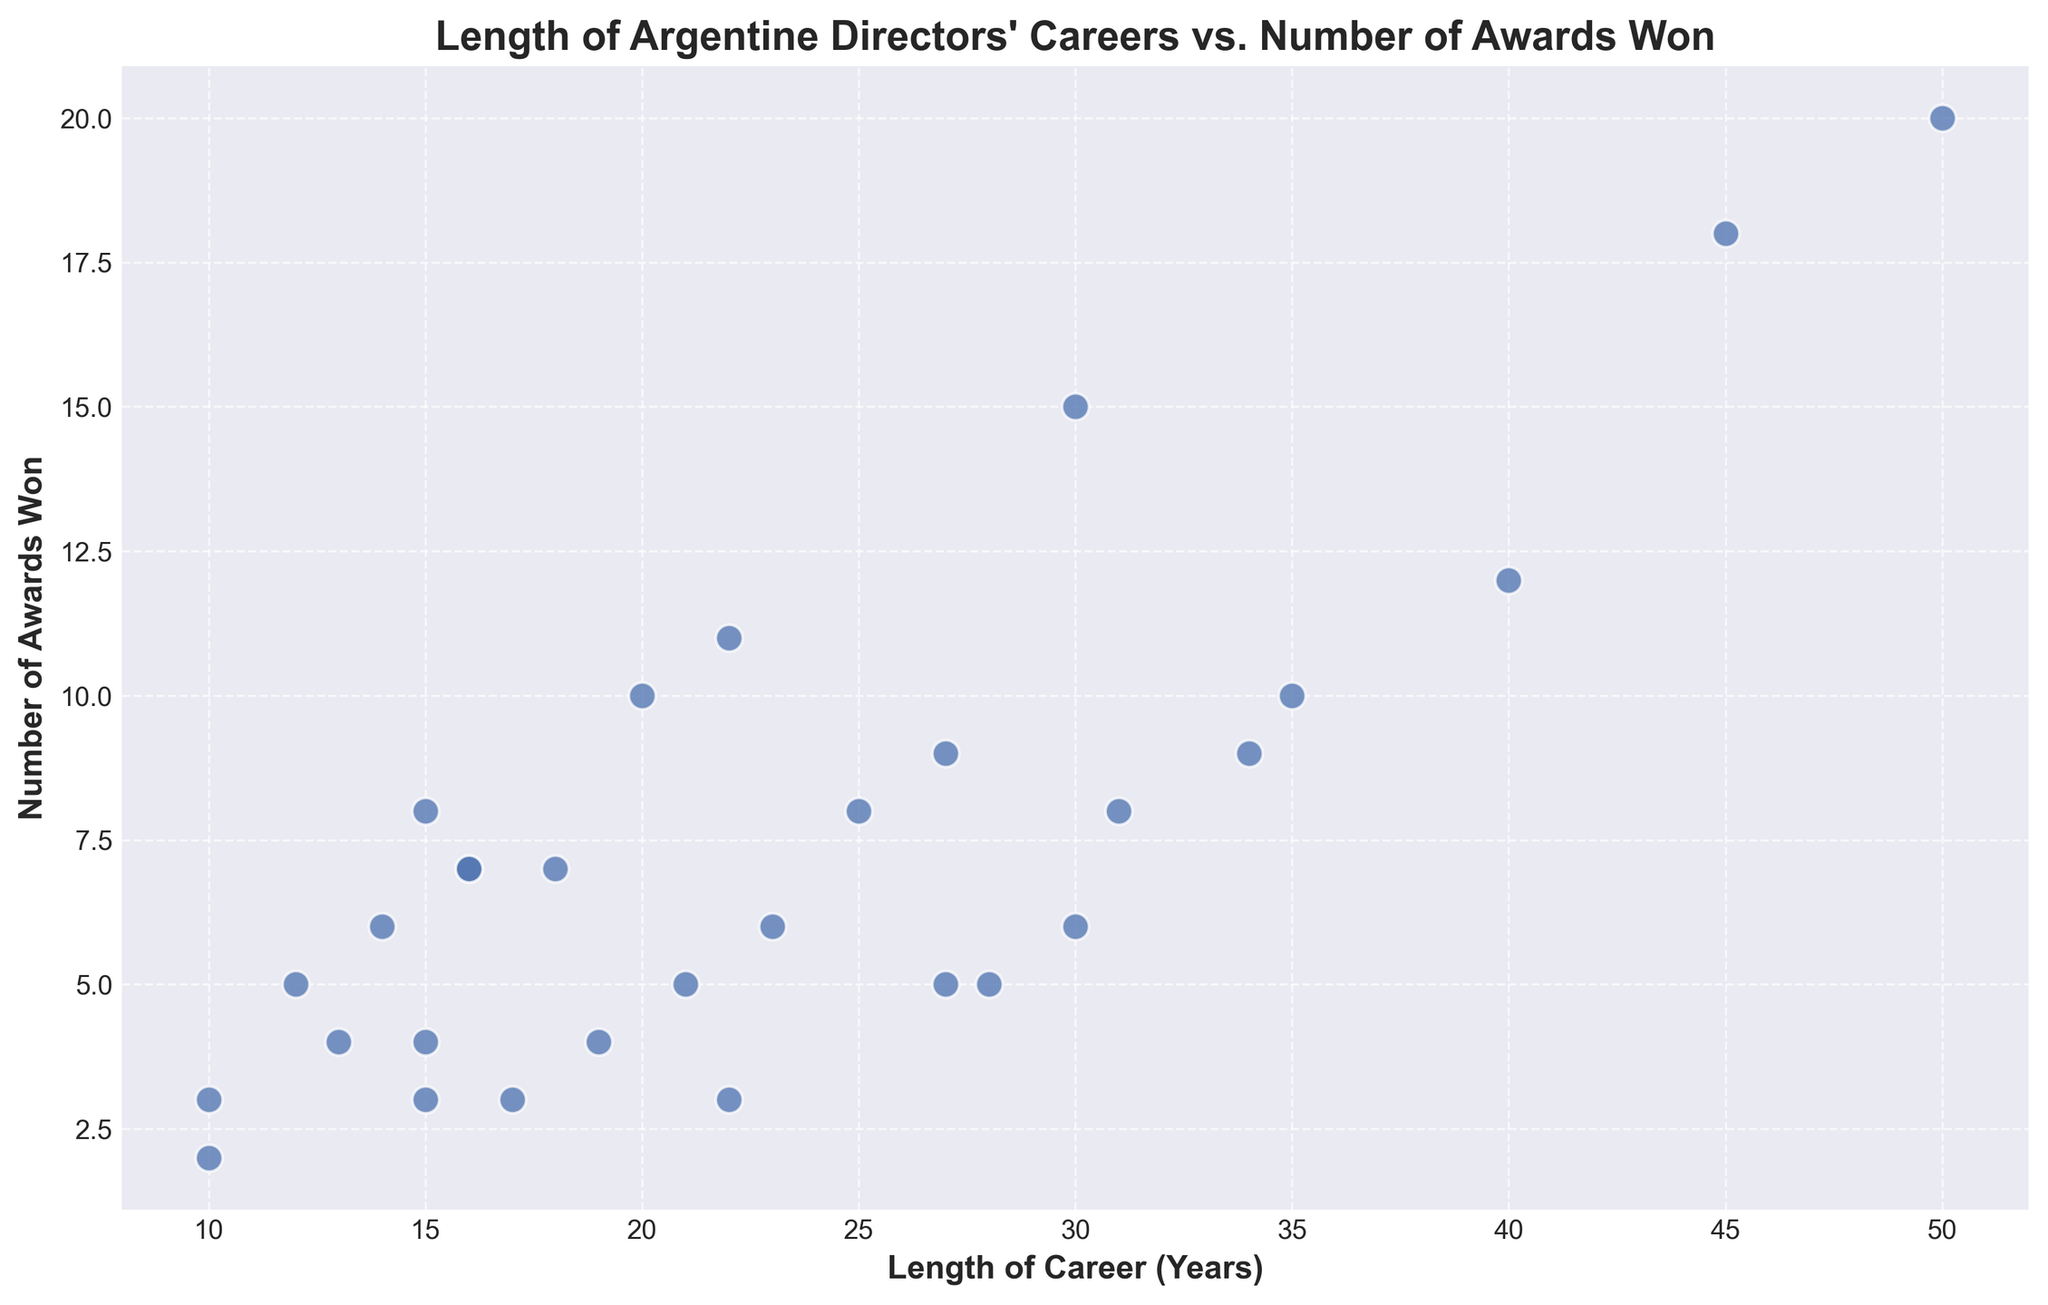What is the maximum number of awards won by any director? To find the maximum number of awards, look at the highest point on the y-axis, which corresponds to the 'Number of Awards Won'.
Answer: 20 Which director has the longest career span? To determine the director with the longest career, look at the rightmost point along the x-axis, representing 'Length of Career (Years)'.
Answer: Leonardo Favio Is there a director with more than 40 years of career and more than 15 awards won? Locate the region on the plot where 'Length of Career (Years)' is greater than 40 and 'Number of Awards Won' is greater than 15.
Answer: Yes, Fernando E. Solanas Do any directors have identical career lengths but different numbers of awards? Check for any vertical alignment of points on the scatter plot; these represent directors with the same career lengths but different awards.
Answer: Yes, Lucrecia Martel appears twice with different award counts What is the average number of awards won by directors with less than 20 years of career? Identify the points where 'Length of Career (Years)' is less than 20. Then, sum up their awards and divide by the number of such points. (6+7+6+5+4+3+3+3+2) = 39; there are 9 points.
Answer: 4.33 Are there more directors with less than 20 awards who have careers longer than 30 years? Count the points where 'Length of Career (Years)' is more than 30 and check if their 'Number of Awards' is less than 20. Compare these against directors with awards equal to or more than 20.
Answer: Yes Which director with a career length of around 30 years has the lowest number of awards? Focus on points around the 30-year mark on the x-axis and identify the lowest among these on the y-axis.
Answer: Hugo Santiago Is there a general trend indicating that longer career lengths correspond to more awards won? Visually inspect the scatter plot to see if there is an upward trend, where points generally rise as they move to the right.
Answer: Yes, generally 